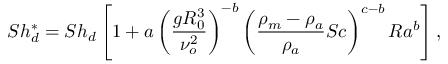Convert formula to latex. <formula><loc_0><loc_0><loc_500><loc_500>S h _ { d } ^ { * } = S h _ { d } \left [ 1 + a \left ( \frac { g R _ { 0 } ^ { 3 } } { \nu _ { o } ^ { 2 } } \right ) ^ { - b } \left ( \frac { \rho _ { m } - \rho _ { a } } { \rho _ { a } } S c \right ) ^ { c - b } R a ^ { b } \right ] ,</formula> 